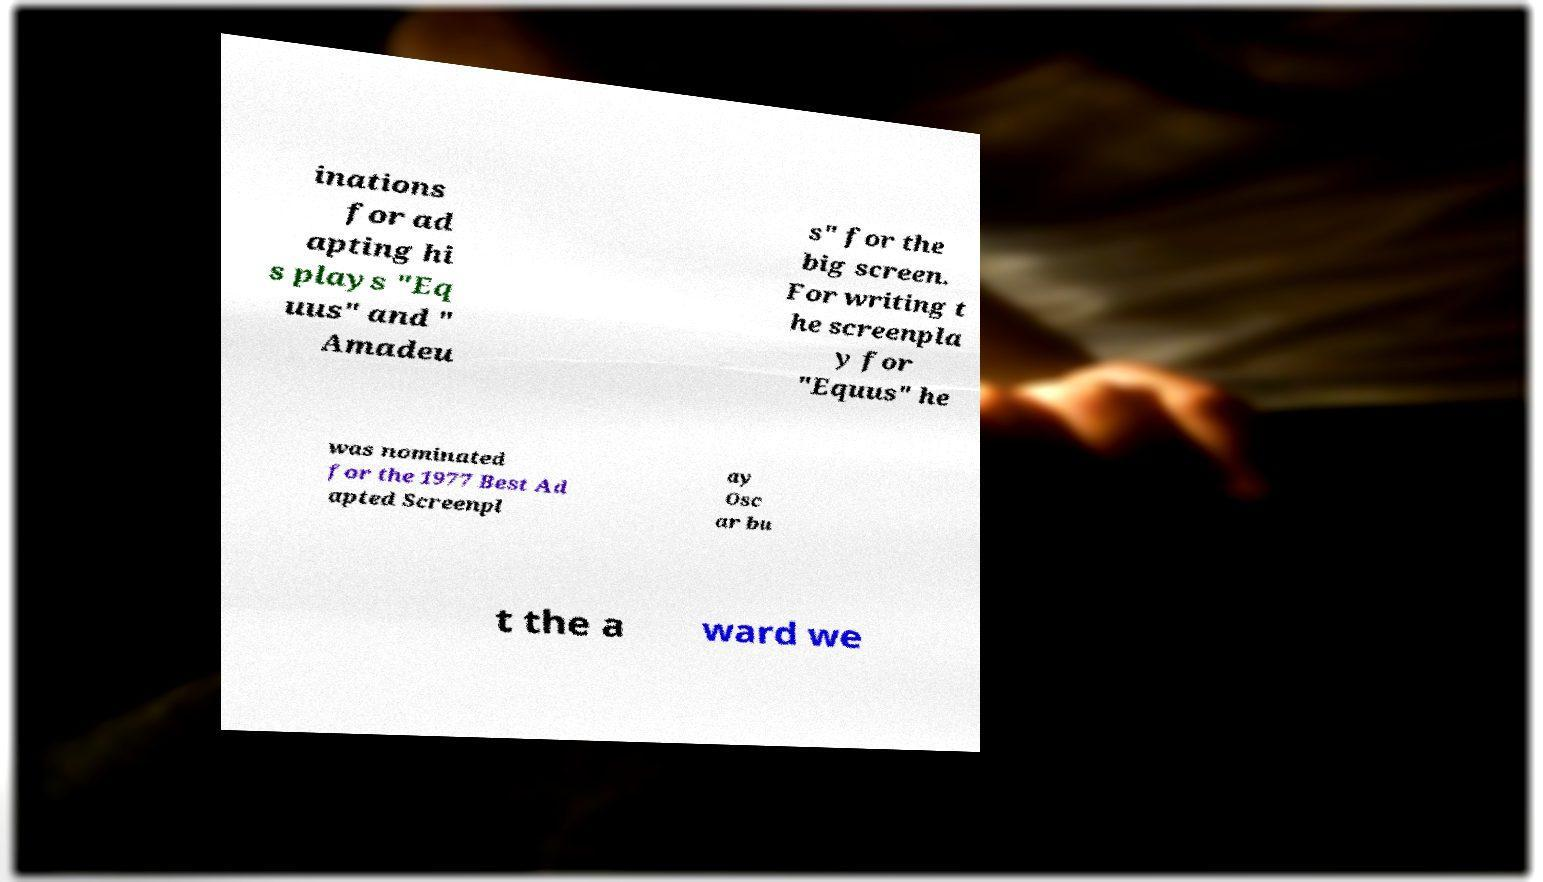Could you assist in decoding the text presented in this image and type it out clearly? inations for ad apting hi s plays "Eq uus" and " Amadeu s" for the big screen. For writing t he screenpla y for "Equus" he was nominated for the 1977 Best Ad apted Screenpl ay Osc ar bu t the a ward we 